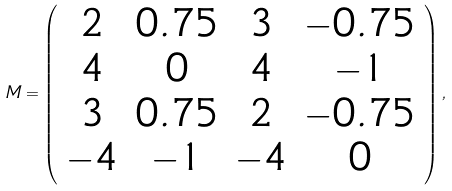<formula> <loc_0><loc_0><loc_500><loc_500>M = \left ( \begin{array} { c c c c } 2 & 0 . 7 5 & 3 & - 0 . 7 5 \\ 4 & 0 & 4 & - 1 \\ 3 & 0 . 7 5 & 2 & - 0 . 7 5 \\ - 4 & - 1 & - 4 & 0 \end{array} \right ) ,</formula> 